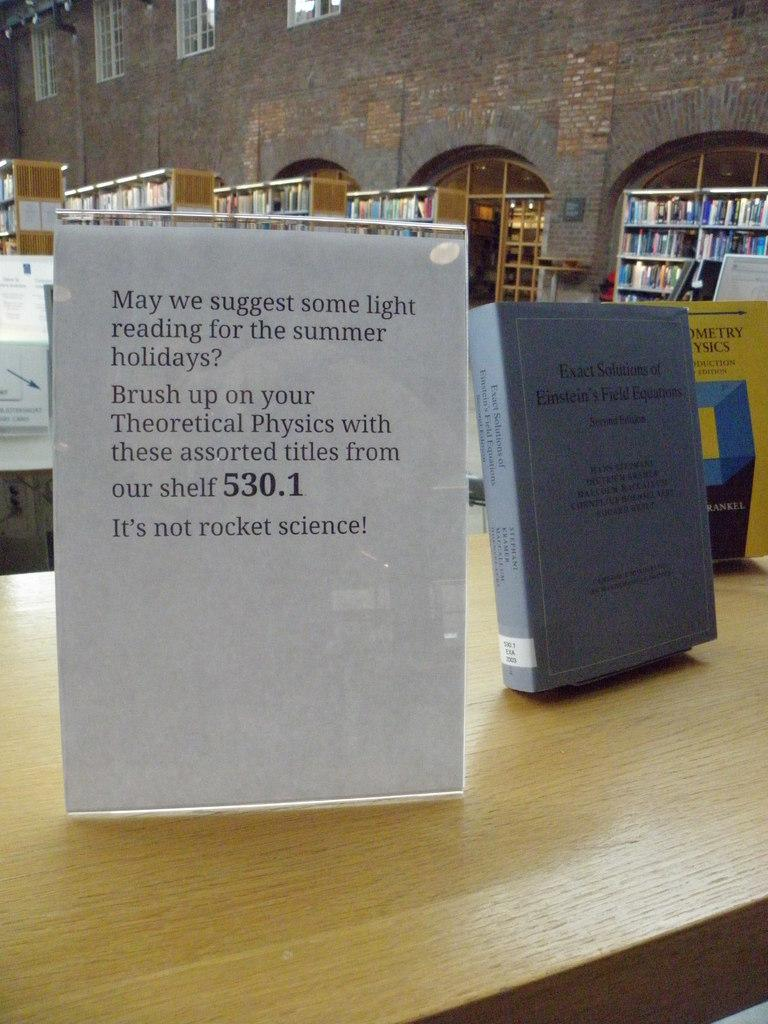<image>
Provide a brief description of the given image. A paper flyer suggesting books about theoretical physics for light summer reading. 